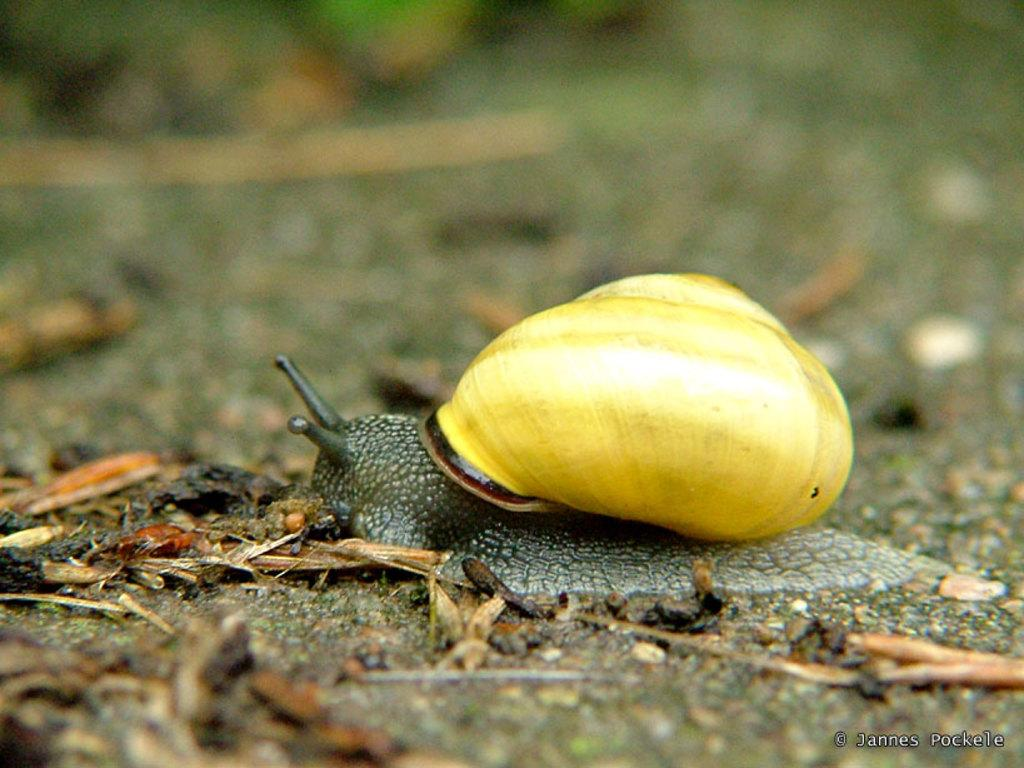What type of animal is in the image? There is a snail in the image. Can you describe the background of the image? The background of the image is blurred. What advice does the snail's mom give in the image? There is no mention of a mom or any advice given in the image, as it only features a snail and a blurred background. 